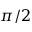Convert formula to latex. <formula><loc_0><loc_0><loc_500><loc_500>\pi / 2</formula> 